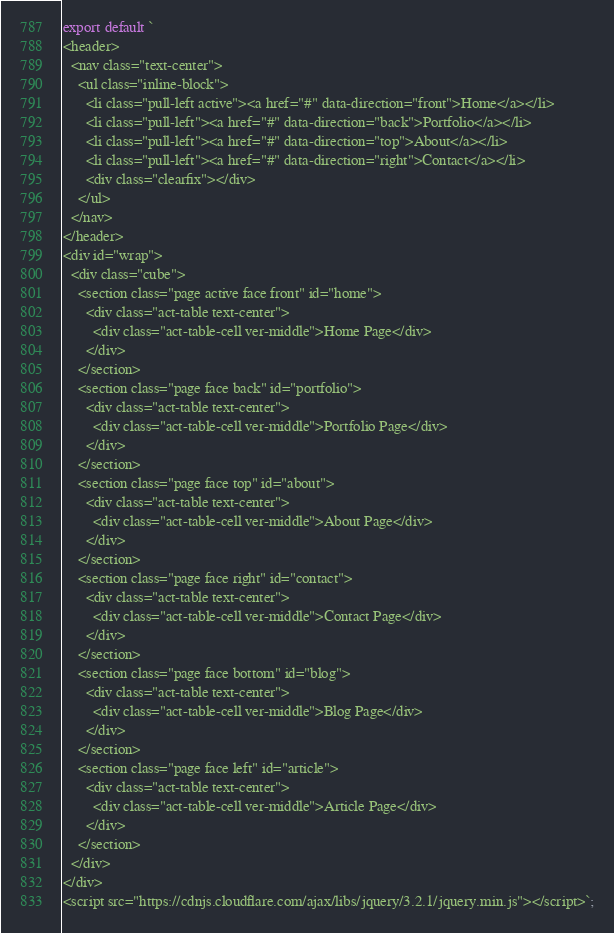Convert code to text. <code><loc_0><loc_0><loc_500><loc_500><_JavaScript_>export default `
<header>
  <nav class="text-center">
    <ul class="inline-block">
      <li class="pull-left active"><a href="#" data-direction="front">Home</a></li>
      <li class="pull-left"><a href="#" data-direction="back">Portfolio</a></li>
      <li class="pull-left"><a href="#" data-direction="top">About</a></li>
      <li class="pull-left"><a href="#" data-direction="right">Contact</a></li>
      <div class="clearfix"></div>
    </ul>
  </nav>
</header>
<div id="wrap">
  <div class="cube">
    <section class="page active face front" id="home">
      <div class="act-table text-center">
        <div class="act-table-cell ver-middle">Home Page</div>
      </div>
    </section>
    <section class="page face back" id="portfolio">
      <div class="act-table text-center">
        <div class="act-table-cell ver-middle">Portfolio Page</div>
      </div>
    </section>
    <section class="page face top" id="about">
      <div class="act-table text-center">
        <div class="act-table-cell ver-middle">About Page</div>
      </div>
    </section>
    <section class="page face right" id="contact">
      <div class="act-table text-center">
        <div class="act-table-cell ver-middle">Contact Page</div>
      </div>
    </section>
    <section class="page face bottom" id="blog">
      <div class="act-table text-center">
        <div class="act-table-cell ver-middle">Blog Page</div>
      </div>
    </section>
    <section class="page face left" id="article">
      <div class="act-table text-center">
        <div class="act-table-cell ver-middle">Article Page</div>
      </div>
    </section>
  </div>
</div>
<script src="https://cdnjs.cloudflare.com/ajax/libs/jquery/3.2.1/jquery.min.js"></script>`;
</code> 